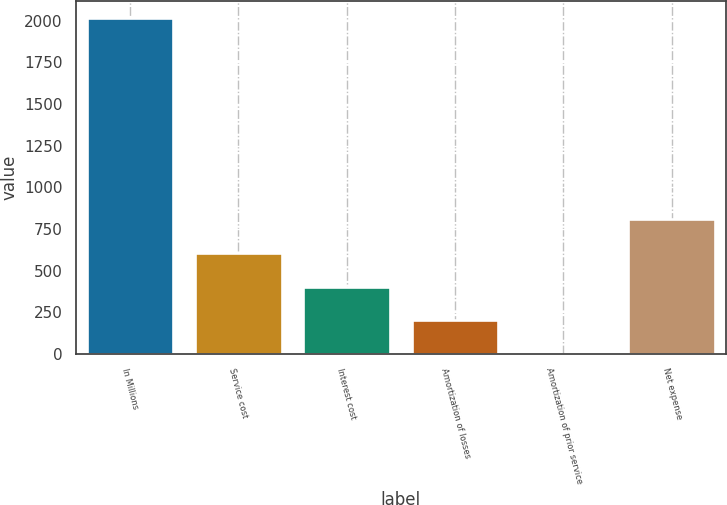<chart> <loc_0><loc_0><loc_500><loc_500><bar_chart><fcel>In Millions<fcel>Service cost<fcel>Interest cost<fcel>Amortization of losses<fcel>Amortization of prior service<fcel>Net expense<nl><fcel>2017<fcel>605.52<fcel>403.88<fcel>202.24<fcel>0.6<fcel>807.16<nl></chart> 